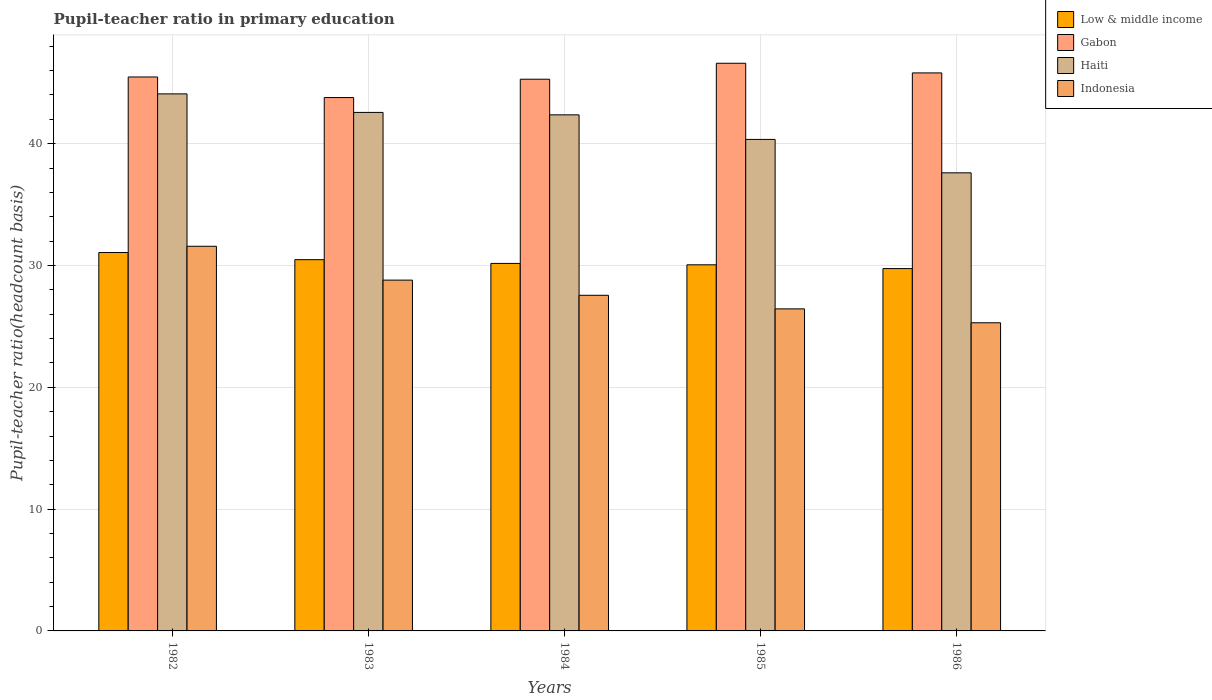How many different coloured bars are there?
Offer a very short reply. 4. Are the number of bars per tick equal to the number of legend labels?
Ensure brevity in your answer.  Yes. Are the number of bars on each tick of the X-axis equal?
Give a very brief answer. Yes. How many bars are there on the 4th tick from the right?
Your response must be concise. 4. In how many cases, is the number of bars for a given year not equal to the number of legend labels?
Keep it short and to the point. 0. What is the pupil-teacher ratio in primary education in Haiti in 1984?
Give a very brief answer. 42.37. Across all years, what is the maximum pupil-teacher ratio in primary education in Low & middle income?
Your answer should be very brief. 31.06. Across all years, what is the minimum pupil-teacher ratio in primary education in Gabon?
Your answer should be compact. 43.79. In which year was the pupil-teacher ratio in primary education in Low & middle income maximum?
Offer a terse response. 1982. What is the total pupil-teacher ratio in primary education in Indonesia in the graph?
Your answer should be compact. 139.67. What is the difference between the pupil-teacher ratio in primary education in Haiti in 1983 and that in 1986?
Your answer should be compact. 4.96. What is the difference between the pupil-teacher ratio in primary education in Low & middle income in 1986 and the pupil-teacher ratio in primary education in Gabon in 1982?
Your answer should be very brief. -15.73. What is the average pupil-teacher ratio in primary education in Low & middle income per year?
Your answer should be compact. 30.3. In the year 1984, what is the difference between the pupil-teacher ratio in primary education in Gabon and pupil-teacher ratio in primary education in Low & middle income?
Your answer should be very brief. 15.12. In how many years, is the pupil-teacher ratio in primary education in Gabon greater than 18?
Your answer should be compact. 5. What is the ratio of the pupil-teacher ratio in primary education in Indonesia in 1985 to that in 1986?
Ensure brevity in your answer.  1.05. Is the difference between the pupil-teacher ratio in primary education in Gabon in 1984 and 1986 greater than the difference between the pupil-teacher ratio in primary education in Low & middle income in 1984 and 1986?
Your response must be concise. No. What is the difference between the highest and the second highest pupil-teacher ratio in primary education in Low & middle income?
Ensure brevity in your answer.  0.59. What is the difference between the highest and the lowest pupil-teacher ratio in primary education in Indonesia?
Give a very brief answer. 6.28. In how many years, is the pupil-teacher ratio in primary education in Gabon greater than the average pupil-teacher ratio in primary education in Gabon taken over all years?
Provide a short and direct response. 3. Is the sum of the pupil-teacher ratio in primary education in Low & middle income in 1982 and 1985 greater than the maximum pupil-teacher ratio in primary education in Indonesia across all years?
Give a very brief answer. Yes. Is it the case that in every year, the sum of the pupil-teacher ratio in primary education in Low & middle income and pupil-teacher ratio in primary education in Gabon is greater than the sum of pupil-teacher ratio in primary education in Indonesia and pupil-teacher ratio in primary education in Haiti?
Offer a terse response. Yes. What does the 2nd bar from the left in 1986 represents?
Your answer should be compact. Gabon. Is it the case that in every year, the sum of the pupil-teacher ratio in primary education in Haiti and pupil-teacher ratio in primary education in Indonesia is greater than the pupil-teacher ratio in primary education in Gabon?
Keep it short and to the point. Yes. What is the difference between two consecutive major ticks on the Y-axis?
Offer a very short reply. 10. Does the graph contain grids?
Offer a terse response. Yes. How many legend labels are there?
Offer a very short reply. 4. How are the legend labels stacked?
Make the answer very short. Vertical. What is the title of the graph?
Keep it short and to the point. Pupil-teacher ratio in primary education. Does "Angola" appear as one of the legend labels in the graph?
Ensure brevity in your answer.  No. What is the label or title of the Y-axis?
Offer a terse response. Pupil-teacher ratio(headcount basis). What is the Pupil-teacher ratio(headcount basis) in Low & middle income in 1982?
Offer a very short reply. 31.06. What is the Pupil-teacher ratio(headcount basis) in Gabon in 1982?
Your response must be concise. 45.48. What is the Pupil-teacher ratio(headcount basis) of Haiti in 1982?
Give a very brief answer. 44.09. What is the Pupil-teacher ratio(headcount basis) in Indonesia in 1982?
Provide a short and direct response. 31.58. What is the Pupil-teacher ratio(headcount basis) in Low & middle income in 1983?
Provide a succinct answer. 30.48. What is the Pupil-teacher ratio(headcount basis) of Gabon in 1983?
Your answer should be compact. 43.79. What is the Pupil-teacher ratio(headcount basis) in Haiti in 1983?
Keep it short and to the point. 42.57. What is the Pupil-teacher ratio(headcount basis) in Indonesia in 1983?
Provide a succinct answer. 28.8. What is the Pupil-teacher ratio(headcount basis) of Low & middle income in 1984?
Provide a short and direct response. 30.17. What is the Pupil-teacher ratio(headcount basis) in Gabon in 1984?
Your answer should be very brief. 45.29. What is the Pupil-teacher ratio(headcount basis) of Haiti in 1984?
Your answer should be compact. 42.37. What is the Pupil-teacher ratio(headcount basis) in Indonesia in 1984?
Ensure brevity in your answer.  27.55. What is the Pupil-teacher ratio(headcount basis) in Low & middle income in 1985?
Your response must be concise. 30.06. What is the Pupil-teacher ratio(headcount basis) of Gabon in 1985?
Your answer should be compact. 46.6. What is the Pupil-teacher ratio(headcount basis) in Haiti in 1985?
Offer a terse response. 40.35. What is the Pupil-teacher ratio(headcount basis) in Indonesia in 1985?
Your answer should be very brief. 26.44. What is the Pupil-teacher ratio(headcount basis) in Low & middle income in 1986?
Your response must be concise. 29.75. What is the Pupil-teacher ratio(headcount basis) in Gabon in 1986?
Provide a succinct answer. 45.81. What is the Pupil-teacher ratio(headcount basis) in Haiti in 1986?
Your response must be concise. 37.61. What is the Pupil-teacher ratio(headcount basis) of Indonesia in 1986?
Offer a very short reply. 25.3. Across all years, what is the maximum Pupil-teacher ratio(headcount basis) in Low & middle income?
Offer a terse response. 31.06. Across all years, what is the maximum Pupil-teacher ratio(headcount basis) in Gabon?
Give a very brief answer. 46.6. Across all years, what is the maximum Pupil-teacher ratio(headcount basis) of Haiti?
Provide a short and direct response. 44.09. Across all years, what is the maximum Pupil-teacher ratio(headcount basis) in Indonesia?
Ensure brevity in your answer.  31.58. Across all years, what is the minimum Pupil-teacher ratio(headcount basis) in Low & middle income?
Ensure brevity in your answer.  29.75. Across all years, what is the minimum Pupil-teacher ratio(headcount basis) of Gabon?
Keep it short and to the point. 43.79. Across all years, what is the minimum Pupil-teacher ratio(headcount basis) of Haiti?
Give a very brief answer. 37.61. Across all years, what is the minimum Pupil-teacher ratio(headcount basis) of Indonesia?
Ensure brevity in your answer.  25.3. What is the total Pupil-teacher ratio(headcount basis) of Low & middle income in the graph?
Your response must be concise. 151.52. What is the total Pupil-teacher ratio(headcount basis) in Gabon in the graph?
Provide a succinct answer. 226.97. What is the total Pupil-teacher ratio(headcount basis) in Haiti in the graph?
Offer a very short reply. 206.98. What is the total Pupil-teacher ratio(headcount basis) in Indonesia in the graph?
Offer a very short reply. 139.67. What is the difference between the Pupil-teacher ratio(headcount basis) in Low & middle income in 1982 and that in 1983?
Your answer should be very brief. 0.59. What is the difference between the Pupil-teacher ratio(headcount basis) in Gabon in 1982 and that in 1983?
Ensure brevity in your answer.  1.69. What is the difference between the Pupil-teacher ratio(headcount basis) in Haiti in 1982 and that in 1983?
Your response must be concise. 1.52. What is the difference between the Pupil-teacher ratio(headcount basis) in Indonesia in 1982 and that in 1983?
Your answer should be compact. 2.78. What is the difference between the Pupil-teacher ratio(headcount basis) in Low & middle income in 1982 and that in 1984?
Ensure brevity in your answer.  0.89. What is the difference between the Pupil-teacher ratio(headcount basis) of Gabon in 1982 and that in 1984?
Give a very brief answer. 0.18. What is the difference between the Pupil-teacher ratio(headcount basis) in Haiti in 1982 and that in 1984?
Your answer should be very brief. 1.72. What is the difference between the Pupil-teacher ratio(headcount basis) in Indonesia in 1982 and that in 1984?
Offer a terse response. 4.02. What is the difference between the Pupil-teacher ratio(headcount basis) of Low & middle income in 1982 and that in 1985?
Your answer should be very brief. 1.01. What is the difference between the Pupil-teacher ratio(headcount basis) of Gabon in 1982 and that in 1985?
Make the answer very short. -1.13. What is the difference between the Pupil-teacher ratio(headcount basis) of Haiti in 1982 and that in 1985?
Keep it short and to the point. 3.74. What is the difference between the Pupil-teacher ratio(headcount basis) in Indonesia in 1982 and that in 1985?
Provide a short and direct response. 5.14. What is the difference between the Pupil-teacher ratio(headcount basis) in Low & middle income in 1982 and that in 1986?
Offer a very short reply. 1.32. What is the difference between the Pupil-teacher ratio(headcount basis) of Gabon in 1982 and that in 1986?
Your answer should be very brief. -0.33. What is the difference between the Pupil-teacher ratio(headcount basis) in Haiti in 1982 and that in 1986?
Your response must be concise. 6.48. What is the difference between the Pupil-teacher ratio(headcount basis) in Indonesia in 1982 and that in 1986?
Make the answer very short. 6.28. What is the difference between the Pupil-teacher ratio(headcount basis) in Low & middle income in 1983 and that in 1984?
Ensure brevity in your answer.  0.31. What is the difference between the Pupil-teacher ratio(headcount basis) in Gabon in 1983 and that in 1984?
Your response must be concise. -1.51. What is the difference between the Pupil-teacher ratio(headcount basis) of Haiti in 1983 and that in 1984?
Your answer should be very brief. 0.2. What is the difference between the Pupil-teacher ratio(headcount basis) in Indonesia in 1983 and that in 1984?
Your response must be concise. 1.25. What is the difference between the Pupil-teacher ratio(headcount basis) in Low & middle income in 1983 and that in 1985?
Offer a terse response. 0.42. What is the difference between the Pupil-teacher ratio(headcount basis) in Gabon in 1983 and that in 1985?
Keep it short and to the point. -2.82. What is the difference between the Pupil-teacher ratio(headcount basis) in Haiti in 1983 and that in 1985?
Your answer should be compact. 2.22. What is the difference between the Pupil-teacher ratio(headcount basis) of Indonesia in 1983 and that in 1985?
Provide a short and direct response. 2.36. What is the difference between the Pupil-teacher ratio(headcount basis) of Low & middle income in 1983 and that in 1986?
Make the answer very short. 0.73. What is the difference between the Pupil-teacher ratio(headcount basis) of Gabon in 1983 and that in 1986?
Keep it short and to the point. -2.02. What is the difference between the Pupil-teacher ratio(headcount basis) of Haiti in 1983 and that in 1986?
Provide a succinct answer. 4.96. What is the difference between the Pupil-teacher ratio(headcount basis) of Indonesia in 1983 and that in 1986?
Provide a succinct answer. 3.5. What is the difference between the Pupil-teacher ratio(headcount basis) in Low & middle income in 1984 and that in 1985?
Make the answer very short. 0.11. What is the difference between the Pupil-teacher ratio(headcount basis) in Gabon in 1984 and that in 1985?
Keep it short and to the point. -1.31. What is the difference between the Pupil-teacher ratio(headcount basis) in Haiti in 1984 and that in 1985?
Offer a terse response. 2.02. What is the difference between the Pupil-teacher ratio(headcount basis) of Indonesia in 1984 and that in 1985?
Give a very brief answer. 1.11. What is the difference between the Pupil-teacher ratio(headcount basis) of Low & middle income in 1984 and that in 1986?
Offer a very short reply. 0.42. What is the difference between the Pupil-teacher ratio(headcount basis) of Gabon in 1984 and that in 1986?
Your answer should be compact. -0.52. What is the difference between the Pupil-teacher ratio(headcount basis) of Haiti in 1984 and that in 1986?
Provide a succinct answer. 4.76. What is the difference between the Pupil-teacher ratio(headcount basis) in Indonesia in 1984 and that in 1986?
Your answer should be very brief. 2.26. What is the difference between the Pupil-teacher ratio(headcount basis) in Low & middle income in 1985 and that in 1986?
Your answer should be very brief. 0.31. What is the difference between the Pupil-teacher ratio(headcount basis) of Gabon in 1985 and that in 1986?
Keep it short and to the point. 0.79. What is the difference between the Pupil-teacher ratio(headcount basis) in Haiti in 1985 and that in 1986?
Ensure brevity in your answer.  2.74. What is the difference between the Pupil-teacher ratio(headcount basis) in Indonesia in 1985 and that in 1986?
Your answer should be very brief. 1.14. What is the difference between the Pupil-teacher ratio(headcount basis) in Low & middle income in 1982 and the Pupil-teacher ratio(headcount basis) in Gabon in 1983?
Provide a succinct answer. -12.72. What is the difference between the Pupil-teacher ratio(headcount basis) of Low & middle income in 1982 and the Pupil-teacher ratio(headcount basis) of Haiti in 1983?
Ensure brevity in your answer.  -11.5. What is the difference between the Pupil-teacher ratio(headcount basis) of Low & middle income in 1982 and the Pupil-teacher ratio(headcount basis) of Indonesia in 1983?
Keep it short and to the point. 2.27. What is the difference between the Pupil-teacher ratio(headcount basis) of Gabon in 1982 and the Pupil-teacher ratio(headcount basis) of Haiti in 1983?
Provide a succinct answer. 2.91. What is the difference between the Pupil-teacher ratio(headcount basis) in Gabon in 1982 and the Pupil-teacher ratio(headcount basis) in Indonesia in 1983?
Your answer should be very brief. 16.68. What is the difference between the Pupil-teacher ratio(headcount basis) in Haiti in 1982 and the Pupil-teacher ratio(headcount basis) in Indonesia in 1983?
Offer a very short reply. 15.29. What is the difference between the Pupil-teacher ratio(headcount basis) in Low & middle income in 1982 and the Pupil-teacher ratio(headcount basis) in Gabon in 1984?
Give a very brief answer. -14.23. What is the difference between the Pupil-teacher ratio(headcount basis) of Low & middle income in 1982 and the Pupil-teacher ratio(headcount basis) of Haiti in 1984?
Keep it short and to the point. -11.3. What is the difference between the Pupil-teacher ratio(headcount basis) of Low & middle income in 1982 and the Pupil-teacher ratio(headcount basis) of Indonesia in 1984?
Offer a very short reply. 3.51. What is the difference between the Pupil-teacher ratio(headcount basis) of Gabon in 1982 and the Pupil-teacher ratio(headcount basis) of Haiti in 1984?
Offer a very short reply. 3.11. What is the difference between the Pupil-teacher ratio(headcount basis) in Gabon in 1982 and the Pupil-teacher ratio(headcount basis) in Indonesia in 1984?
Keep it short and to the point. 17.92. What is the difference between the Pupil-teacher ratio(headcount basis) of Haiti in 1982 and the Pupil-teacher ratio(headcount basis) of Indonesia in 1984?
Keep it short and to the point. 16.53. What is the difference between the Pupil-teacher ratio(headcount basis) of Low & middle income in 1982 and the Pupil-teacher ratio(headcount basis) of Gabon in 1985?
Offer a very short reply. -15.54. What is the difference between the Pupil-teacher ratio(headcount basis) in Low & middle income in 1982 and the Pupil-teacher ratio(headcount basis) in Haiti in 1985?
Your response must be concise. -9.29. What is the difference between the Pupil-teacher ratio(headcount basis) in Low & middle income in 1982 and the Pupil-teacher ratio(headcount basis) in Indonesia in 1985?
Give a very brief answer. 4.63. What is the difference between the Pupil-teacher ratio(headcount basis) of Gabon in 1982 and the Pupil-teacher ratio(headcount basis) of Haiti in 1985?
Your response must be concise. 5.13. What is the difference between the Pupil-teacher ratio(headcount basis) of Gabon in 1982 and the Pupil-teacher ratio(headcount basis) of Indonesia in 1985?
Ensure brevity in your answer.  19.04. What is the difference between the Pupil-teacher ratio(headcount basis) in Haiti in 1982 and the Pupil-teacher ratio(headcount basis) in Indonesia in 1985?
Your answer should be compact. 17.65. What is the difference between the Pupil-teacher ratio(headcount basis) in Low & middle income in 1982 and the Pupil-teacher ratio(headcount basis) in Gabon in 1986?
Keep it short and to the point. -14.75. What is the difference between the Pupil-teacher ratio(headcount basis) of Low & middle income in 1982 and the Pupil-teacher ratio(headcount basis) of Haiti in 1986?
Your answer should be very brief. -6.54. What is the difference between the Pupil-teacher ratio(headcount basis) of Low & middle income in 1982 and the Pupil-teacher ratio(headcount basis) of Indonesia in 1986?
Offer a terse response. 5.77. What is the difference between the Pupil-teacher ratio(headcount basis) in Gabon in 1982 and the Pupil-teacher ratio(headcount basis) in Haiti in 1986?
Offer a terse response. 7.87. What is the difference between the Pupil-teacher ratio(headcount basis) in Gabon in 1982 and the Pupil-teacher ratio(headcount basis) in Indonesia in 1986?
Provide a short and direct response. 20.18. What is the difference between the Pupil-teacher ratio(headcount basis) of Haiti in 1982 and the Pupil-teacher ratio(headcount basis) of Indonesia in 1986?
Give a very brief answer. 18.79. What is the difference between the Pupil-teacher ratio(headcount basis) in Low & middle income in 1983 and the Pupil-teacher ratio(headcount basis) in Gabon in 1984?
Provide a succinct answer. -14.81. What is the difference between the Pupil-teacher ratio(headcount basis) in Low & middle income in 1983 and the Pupil-teacher ratio(headcount basis) in Haiti in 1984?
Your response must be concise. -11.89. What is the difference between the Pupil-teacher ratio(headcount basis) in Low & middle income in 1983 and the Pupil-teacher ratio(headcount basis) in Indonesia in 1984?
Provide a short and direct response. 2.92. What is the difference between the Pupil-teacher ratio(headcount basis) of Gabon in 1983 and the Pupil-teacher ratio(headcount basis) of Haiti in 1984?
Your answer should be very brief. 1.42. What is the difference between the Pupil-teacher ratio(headcount basis) in Gabon in 1983 and the Pupil-teacher ratio(headcount basis) in Indonesia in 1984?
Your response must be concise. 16.23. What is the difference between the Pupil-teacher ratio(headcount basis) in Haiti in 1983 and the Pupil-teacher ratio(headcount basis) in Indonesia in 1984?
Give a very brief answer. 15.01. What is the difference between the Pupil-teacher ratio(headcount basis) in Low & middle income in 1983 and the Pupil-teacher ratio(headcount basis) in Gabon in 1985?
Your answer should be compact. -16.12. What is the difference between the Pupil-teacher ratio(headcount basis) in Low & middle income in 1983 and the Pupil-teacher ratio(headcount basis) in Haiti in 1985?
Ensure brevity in your answer.  -9.87. What is the difference between the Pupil-teacher ratio(headcount basis) in Low & middle income in 1983 and the Pupil-teacher ratio(headcount basis) in Indonesia in 1985?
Your answer should be very brief. 4.04. What is the difference between the Pupil-teacher ratio(headcount basis) of Gabon in 1983 and the Pupil-teacher ratio(headcount basis) of Haiti in 1985?
Make the answer very short. 3.44. What is the difference between the Pupil-teacher ratio(headcount basis) in Gabon in 1983 and the Pupil-teacher ratio(headcount basis) in Indonesia in 1985?
Give a very brief answer. 17.35. What is the difference between the Pupil-teacher ratio(headcount basis) of Haiti in 1983 and the Pupil-teacher ratio(headcount basis) of Indonesia in 1985?
Offer a terse response. 16.13. What is the difference between the Pupil-teacher ratio(headcount basis) of Low & middle income in 1983 and the Pupil-teacher ratio(headcount basis) of Gabon in 1986?
Ensure brevity in your answer.  -15.33. What is the difference between the Pupil-teacher ratio(headcount basis) in Low & middle income in 1983 and the Pupil-teacher ratio(headcount basis) in Haiti in 1986?
Provide a short and direct response. -7.13. What is the difference between the Pupil-teacher ratio(headcount basis) in Low & middle income in 1983 and the Pupil-teacher ratio(headcount basis) in Indonesia in 1986?
Give a very brief answer. 5.18. What is the difference between the Pupil-teacher ratio(headcount basis) of Gabon in 1983 and the Pupil-teacher ratio(headcount basis) of Haiti in 1986?
Give a very brief answer. 6.18. What is the difference between the Pupil-teacher ratio(headcount basis) of Gabon in 1983 and the Pupil-teacher ratio(headcount basis) of Indonesia in 1986?
Provide a succinct answer. 18.49. What is the difference between the Pupil-teacher ratio(headcount basis) in Haiti in 1983 and the Pupil-teacher ratio(headcount basis) in Indonesia in 1986?
Your response must be concise. 17.27. What is the difference between the Pupil-teacher ratio(headcount basis) in Low & middle income in 1984 and the Pupil-teacher ratio(headcount basis) in Gabon in 1985?
Your answer should be compact. -16.43. What is the difference between the Pupil-teacher ratio(headcount basis) of Low & middle income in 1984 and the Pupil-teacher ratio(headcount basis) of Haiti in 1985?
Your answer should be compact. -10.18. What is the difference between the Pupil-teacher ratio(headcount basis) in Low & middle income in 1984 and the Pupil-teacher ratio(headcount basis) in Indonesia in 1985?
Your answer should be compact. 3.73. What is the difference between the Pupil-teacher ratio(headcount basis) of Gabon in 1984 and the Pupil-teacher ratio(headcount basis) of Haiti in 1985?
Your response must be concise. 4.94. What is the difference between the Pupil-teacher ratio(headcount basis) in Gabon in 1984 and the Pupil-teacher ratio(headcount basis) in Indonesia in 1985?
Your answer should be compact. 18.85. What is the difference between the Pupil-teacher ratio(headcount basis) in Haiti in 1984 and the Pupil-teacher ratio(headcount basis) in Indonesia in 1985?
Offer a very short reply. 15.93. What is the difference between the Pupil-teacher ratio(headcount basis) of Low & middle income in 1984 and the Pupil-teacher ratio(headcount basis) of Gabon in 1986?
Your answer should be very brief. -15.64. What is the difference between the Pupil-teacher ratio(headcount basis) in Low & middle income in 1984 and the Pupil-teacher ratio(headcount basis) in Haiti in 1986?
Make the answer very short. -7.44. What is the difference between the Pupil-teacher ratio(headcount basis) in Low & middle income in 1984 and the Pupil-teacher ratio(headcount basis) in Indonesia in 1986?
Your answer should be very brief. 4.87. What is the difference between the Pupil-teacher ratio(headcount basis) in Gabon in 1984 and the Pupil-teacher ratio(headcount basis) in Haiti in 1986?
Your answer should be very brief. 7.68. What is the difference between the Pupil-teacher ratio(headcount basis) in Gabon in 1984 and the Pupil-teacher ratio(headcount basis) in Indonesia in 1986?
Give a very brief answer. 19.99. What is the difference between the Pupil-teacher ratio(headcount basis) of Haiti in 1984 and the Pupil-teacher ratio(headcount basis) of Indonesia in 1986?
Ensure brevity in your answer.  17.07. What is the difference between the Pupil-teacher ratio(headcount basis) of Low & middle income in 1985 and the Pupil-teacher ratio(headcount basis) of Gabon in 1986?
Ensure brevity in your answer.  -15.75. What is the difference between the Pupil-teacher ratio(headcount basis) of Low & middle income in 1985 and the Pupil-teacher ratio(headcount basis) of Haiti in 1986?
Keep it short and to the point. -7.55. What is the difference between the Pupil-teacher ratio(headcount basis) of Low & middle income in 1985 and the Pupil-teacher ratio(headcount basis) of Indonesia in 1986?
Ensure brevity in your answer.  4.76. What is the difference between the Pupil-teacher ratio(headcount basis) in Gabon in 1985 and the Pupil-teacher ratio(headcount basis) in Haiti in 1986?
Keep it short and to the point. 8.99. What is the difference between the Pupil-teacher ratio(headcount basis) of Gabon in 1985 and the Pupil-teacher ratio(headcount basis) of Indonesia in 1986?
Give a very brief answer. 21.3. What is the difference between the Pupil-teacher ratio(headcount basis) of Haiti in 1985 and the Pupil-teacher ratio(headcount basis) of Indonesia in 1986?
Keep it short and to the point. 15.05. What is the average Pupil-teacher ratio(headcount basis) in Low & middle income per year?
Make the answer very short. 30.3. What is the average Pupil-teacher ratio(headcount basis) of Gabon per year?
Keep it short and to the point. 45.39. What is the average Pupil-teacher ratio(headcount basis) of Haiti per year?
Offer a very short reply. 41.4. What is the average Pupil-teacher ratio(headcount basis) of Indonesia per year?
Keep it short and to the point. 27.93. In the year 1982, what is the difference between the Pupil-teacher ratio(headcount basis) in Low & middle income and Pupil-teacher ratio(headcount basis) in Gabon?
Your answer should be compact. -14.41. In the year 1982, what is the difference between the Pupil-teacher ratio(headcount basis) of Low & middle income and Pupil-teacher ratio(headcount basis) of Haiti?
Make the answer very short. -13.02. In the year 1982, what is the difference between the Pupil-teacher ratio(headcount basis) of Low & middle income and Pupil-teacher ratio(headcount basis) of Indonesia?
Your answer should be compact. -0.51. In the year 1982, what is the difference between the Pupil-teacher ratio(headcount basis) in Gabon and Pupil-teacher ratio(headcount basis) in Haiti?
Give a very brief answer. 1.39. In the year 1982, what is the difference between the Pupil-teacher ratio(headcount basis) in Gabon and Pupil-teacher ratio(headcount basis) in Indonesia?
Offer a terse response. 13.9. In the year 1982, what is the difference between the Pupil-teacher ratio(headcount basis) in Haiti and Pupil-teacher ratio(headcount basis) in Indonesia?
Offer a very short reply. 12.51. In the year 1983, what is the difference between the Pupil-teacher ratio(headcount basis) of Low & middle income and Pupil-teacher ratio(headcount basis) of Gabon?
Offer a very short reply. -13.31. In the year 1983, what is the difference between the Pupil-teacher ratio(headcount basis) of Low & middle income and Pupil-teacher ratio(headcount basis) of Haiti?
Make the answer very short. -12.09. In the year 1983, what is the difference between the Pupil-teacher ratio(headcount basis) in Low & middle income and Pupil-teacher ratio(headcount basis) in Indonesia?
Make the answer very short. 1.68. In the year 1983, what is the difference between the Pupil-teacher ratio(headcount basis) in Gabon and Pupil-teacher ratio(headcount basis) in Haiti?
Your answer should be very brief. 1.22. In the year 1983, what is the difference between the Pupil-teacher ratio(headcount basis) in Gabon and Pupil-teacher ratio(headcount basis) in Indonesia?
Your answer should be very brief. 14.99. In the year 1983, what is the difference between the Pupil-teacher ratio(headcount basis) in Haiti and Pupil-teacher ratio(headcount basis) in Indonesia?
Make the answer very short. 13.77. In the year 1984, what is the difference between the Pupil-teacher ratio(headcount basis) in Low & middle income and Pupil-teacher ratio(headcount basis) in Gabon?
Your answer should be compact. -15.12. In the year 1984, what is the difference between the Pupil-teacher ratio(headcount basis) of Low & middle income and Pupil-teacher ratio(headcount basis) of Haiti?
Ensure brevity in your answer.  -12.2. In the year 1984, what is the difference between the Pupil-teacher ratio(headcount basis) of Low & middle income and Pupil-teacher ratio(headcount basis) of Indonesia?
Your answer should be compact. 2.62. In the year 1984, what is the difference between the Pupil-teacher ratio(headcount basis) of Gabon and Pupil-teacher ratio(headcount basis) of Haiti?
Make the answer very short. 2.93. In the year 1984, what is the difference between the Pupil-teacher ratio(headcount basis) in Gabon and Pupil-teacher ratio(headcount basis) in Indonesia?
Your answer should be very brief. 17.74. In the year 1984, what is the difference between the Pupil-teacher ratio(headcount basis) in Haiti and Pupil-teacher ratio(headcount basis) in Indonesia?
Keep it short and to the point. 14.81. In the year 1985, what is the difference between the Pupil-teacher ratio(headcount basis) of Low & middle income and Pupil-teacher ratio(headcount basis) of Gabon?
Provide a succinct answer. -16.55. In the year 1985, what is the difference between the Pupil-teacher ratio(headcount basis) of Low & middle income and Pupil-teacher ratio(headcount basis) of Haiti?
Your answer should be compact. -10.29. In the year 1985, what is the difference between the Pupil-teacher ratio(headcount basis) in Low & middle income and Pupil-teacher ratio(headcount basis) in Indonesia?
Your response must be concise. 3.62. In the year 1985, what is the difference between the Pupil-teacher ratio(headcount basis) in Gabon and Pupil-teacher ratio(headcount basis) in Haiti?
Offer a terse response. 6.25. In the year 1985, what is the difference between the Pupil-teacher ratio(headcount basis) in Gabon and Pupil-teacher ratio(headcount basis) in Indonesia?
Make the answer very short. 20.16. In the year 1985, what is the difference between the Pupil-teacher ratio(headcount basis) in Haiti and Pupil-teacher ratio(headcount basis) in Indonesia?
Give a very brief answer. 13.91. In the year 1986, what is the difference between the Pupil-teacher ratio(headcount basis) in Low & middle income and Pupil-teacher ratio(headcount basis) in Gabon?
Your answer should be compact. -16.06. In the year 1986, what is the difference between the Pupil-teacher ratio(headcount basis) in Low & middle income and Pupil-teacher ratio(headcount basis) in Haiti?
Offer a very short reply. -7.86. In the year 1986, what is the difference between the Pupil-teacher ratio(headcount basis) of Low & middle income and Pupil-teacher ratio(headcount basis) of Indonesia?
Ensure brevity in your answer.  4.45. In the year 1986, what is the difference between the Pupil-teacher ratio(headcount basis) of Gabon and Pupil-teacher ratio(headcount basis) of Haiti?
Provide a short and direct response. 8.2. In the year 1986, what is the difference between the Pupil-teacher ratio(headcount basis) in Gabon and Pupil-teacher ratio(headcount basis) in Indonesia?
Keep it short and to the point. 20.51. In the year 1986, what is the difference between the Pupil-teacher ratio(headcount basis) in Haiti and Pupil-teacher ratio(headcount basis) in Indonesia?
Your answer should be very brief. 12.31. What is the ratio of the Pupil-teacher ratio(headcount basis) of Low & middle income in 1982 to that in 1983?
Provide a short and direct response. 1.02. What is the ratio of the Pupil-teacher ratio(headcount basis) of Gabon in 1982 to that in 1983?
Make the answer very short. 1.04. What is the ratio of the Pupil-teacher ratio(headcount basis) of Haiti in 1982 to that in 1983?
Make the answer very short. 1.04. What is the ratio of the Pupil-teacher ratio(headcount basis) of Indonesia in 1982 to that in 1983?
Provide a short and direct response. 1.1. What is the ratio of the Pupil-teacher ratio(headcount basis) in Low & middle income in 1982 to that in 1984?
Offer a terse response. 1.03. What is the ratio of the Pupil-teacher ratio(headcount basis) in Gabon in 1982 to that in 1984?
Offer a very short reply. 1. What is the ratio of the Pupil-teacher ratio(headcount basis) in Haiti in 1982 to that in 1984?
Give a very brief answer. 1.04. What is the ratio of the Pupil-teacher ratio(headcount basis) in Indonesia in 1982 to that in 1984?
Offer a terse response. 1.15. What is the ratio of the Pupil-teacher ratio(headcount basis) of Low & middle income in 1982 to that in 1985?
Your answer should be very brief. 1.03. What is the ratio of the Pupil-teacher ratio(headcount basis) of Gabon in 1982 to that in 1985?
Offer a very short reply. 0.98. What is the ratio of the Pupil-teacher ratio(headcount basis) of Haiti in 1982 to that in 1985?
Provide a succinct answer. 1.09. What is the ratio of the Pupil-teacher ratio(headcount basis) in Indonesia in 1982 to that in 1985?
Offer a terse response. 1.19. What is the ratio of the Pupil-teacher ratio(headcount basis) in Low & middle income in 1982 to that in 1986?
Provide a short and direct response. 1.04. What is the ratio of the Pupil-teacher ratio(headcount basis) of Haiti in 1982 to that in 1986?
Your answer should be compact. 1.17. What is the ratio of the Pupil-teacher ratio(headcount basis) of Indonesia in 1982 to that in 1986?
Give a very brief answer. 1.25. What is the ratio of the Pupil-teacher ratio(headcount basis) of Low & middle income in 1983 to that in 1984?
Provide a succinct answer. 1.01. What is the ratio of the Pupil-teacher ratio(headcount basis) in Gabon in 1983 to that in 1984?
Your answer should be very brief. 0.97. What is the ratio of the Pupil-teacher ratio(headcount basis) of Haiti in 1983 to that in 1984?
Offer a very short reply. 1. What is the ratio of the Pupil-teacher ratio(headcount basis) in Indonesia in 1983 to that in 1984?
Your answer should be very brief. 1.05. What is the ratio of the Pupil-teacher ratio(headcount basis) of Gabon in 1983 to that in 1985?
Make the answer very short. 0.94. What is the ratio of the Pupil-teacher ratio(headcount basis) in Haiti in 1983 to that in 1985?
Provide a short and direct response. 1.05. What is the ratio of the Pupil-teacher ratio(headcount basis) of Indonesia in 1983 to that in 1985?
Offer a very short reply. 1.09. What is the ratio of the Pupil-teacher ratio(headcount basis) of Low & middle income in 1983 to that in 1986?
Offer a very short reply. 1.02. What is the ratio of the Pupil-teacher ratio(headcount basis) of Gabon in 1983 to that in 1986?
Make the answer very short. 0.96. What is the ratio of the Pupil-teacher ratio(headcount basis) in Haiti in 1983 to that in 1986?
Give a very brief answer. 1.13. What is the ratio of the Pupil-teacher ratio(headcount basis) of Indonesia in 1983 to that in 1986?
Provide a succinct answer. 1.14. What is the ratio of the Pupil-teacher ratio(headcount basis) in Low & middle income in 1984 to that in 1985?
Provide a short and direct response. 1. What is the ratio of the Pupil-teacher ratio(headcount basis) of Gabon in 1984 to that in 1985?
Give a very brief answer. 0.97. What is the ratio of the Pupil-teacher ratio(headcount basis) of Haiti in 1984 to that in 1985?
Your answer should be very brief. 1.05. What is the ratio of the Pupil-teacher ratio(headcount basis) in Indonesia in 1984 to that in 1985?
Provide a short and direct response. 1.04. What is the ratio of the Pupil-teacher ratio(headcount basis) in Low & middle income in 1984 to that in 1986?
Offer a very short reply. 1.01. What is the ratio of the Pupil-teacher ratio(headcount basis) in Gabon in 1984 to that in 1986?
Offer a terse response. 0.99. What is the ratio of the Pupil-teacher ratio(headcount basis) of Haiti in 1984 to that in 1986?
Provide a succinct answer. 1.13. What is the ratio of the Pupil-teacher ratio(headcount basis) of Indonesia in 1984 to that in 1986?
Make the answer very short. 1.09. What is the ratio of the Pupil-teacher ratio(headcount basis) in Low & middle income in 1985 to that in 1986?
Ensure brevity in your answer.  1.01. What is the ratio of the Pupil-teacher ratio(headcount basis) in Gabon in 1985 to that in 1986?
Keep it short and to the point. 1.02. What is the ratio of the Pupil-teacher ratio(headcount basis) of Haiti in 1985 to that in 1986?
Offer a very short reply. 1.07. What is the ratio of the Pupil-teacher ratio(headcount basis) in Indonesia in 1985 to that in 1986?
Provide a short and direct response. 1.05. What is the difference between the highest and the second highest Pupil-teacher ratio(headcount basis) of Low & middle income?
Ensure brevity in your answer.  0.59. What is the difference between the highest and the second highest Pupil-teacher ratio(headcount basis) of Gabon?
Keep it short and to the point. 0.79. What is the difference between the highest and the second highest Pupil-teacher ratio(headcount basis) in Haiti?
Ensure brevity in your answer.  1.52. What is the difference between the highest and the second highest Pupil-teacher ratio(headcount basis) in Indonesia?
Your answer should be very brief. 2.78. What is the difference between the highest and the lowest Pupil-teacher ratio(headcount basis) in Low & middle income?
Make the answer very short. 1.32. What is the difference between the highest and the lowest Pupil-teacher ratio(headcount basis) in Gabon?
Make the answer very short. 2.82. What is the difference between the highest and the lowest Pupil-teacher ratio(headcount basis) in Haiti?
Give a very brief answer. 6.48. What is the difference between the highest and the lowest Pupil-teacher ratio(headcount basis) of Indonesia?
Your response must be concise. 6.28. 